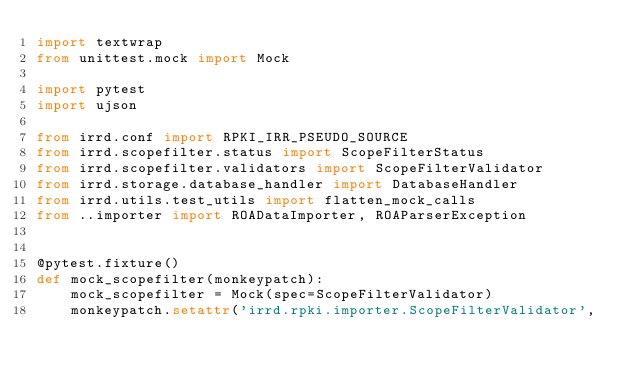<code> <loc_0><loc_0><loc_500><loc_500><_Python_>import textwrap
from unittest.mock import Mock

import pytest
import ujson

from irrd.conf import RPKI_IRR_PSEUDO_SOURCE
from irrd.scopefilter.status import ScopeFilterStatus
from irrd.scopefilter.validators import ScopeFilterValidator
from irrd.storage.database_handler import DatabaseHandler
from irrd.utils.test_utils import flatten_mock_calls
from ..importer import ROADataImporter, ROAParserException


@pytest.fixture()
def mock_scopefilter(monkeypatch):
    mock_scopefilter = Mock(spec=ScopeFilterValidator)
    monkeypatch.setattr('irrd.rpki.importer.ScopeFilterValidator',</code> 